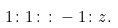<formula> <loc_0><loc_0><loc_500><loc_500>1 \colon 1 \colon \colon - 1 \colon z .</formula> 